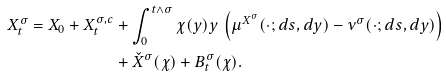<formula> <loc_0><loc_0><loc_500><loc_500>X _ { t } ^ { \sigma } = X _ { 0 } + X _ { t } ^ { \sigma , c } & + \int _ { 0 } ^ { t \wedge \sigma } \chi ( y ) y \ \left ( \mu ^ { X ^ { \sigma } } ( \cdot ; d s , d y ) - \nu ^ { \sigma } ( \cdot ; d s , d y ) \right ) \\ & + \check { X } ^ { \sigma } ( \chi ) + B _ { t } ^ { \sigma } ( \chi ) .</formula> 